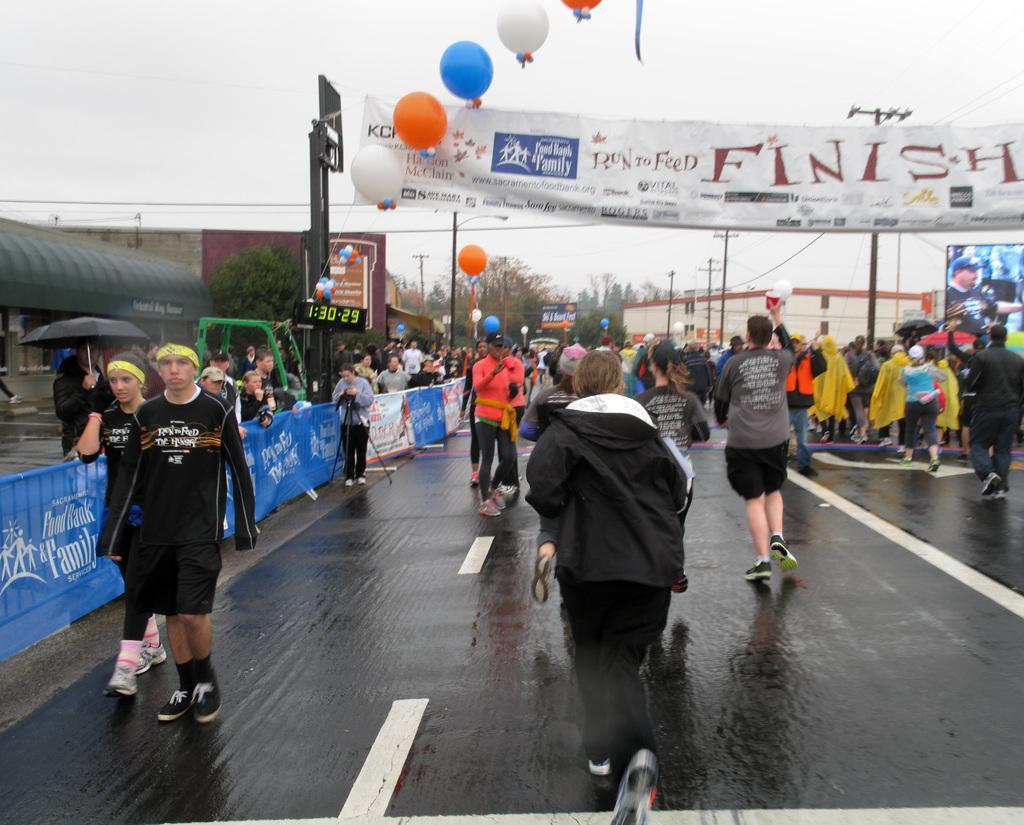Please provide a concise description of this image. In this image there are so many people walking on the road, also there is a banner and balloons at the top, beside the road there are buildings and trees beside them. 